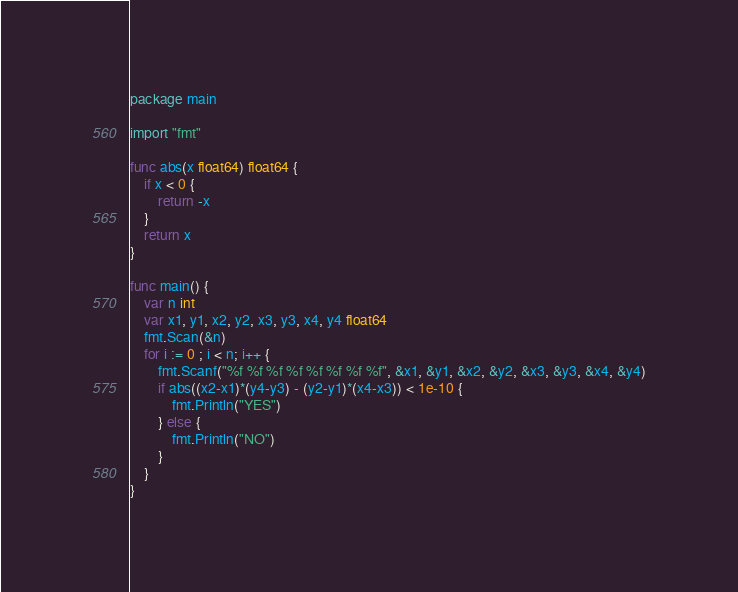Convert code to text. <code><loc_0><loc_0><loc_500><loc_500><_Go_>package main

import "fmt"

func abs(x float64) float64 {
	if x < 0 {
		return -x
	}
	return x
}

func main() {
	var n int
	var x1, y1, x2, y2, x3, y3, x4, y4 float64
	fmt.Scan(&n)
	for i := 0 ; i < n; i++ {
		fmt.Scanf("%f %f %f %f %f %f %f %f", &x1, &y1, &x2, &y2, &x3, &y3, &x4, &y4)
		if abs((x2-x1)*(y4-y3) - (y2-y1)*(x4-x3)) < 1e-10 {
			fmt.Println("YES")
		} else {
			fmt.Println("NO")
		}
	}
}
</code> 